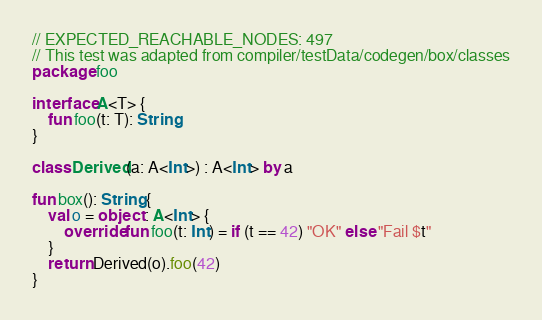<code> <loc_0><loc_0><loc_500><loc_500><_Kotlin_>// EXPECTED_REACHABLE_NODES: 497
// This test was adapted from compiler/testData/codegen/box/classes
package foo

interface A<T> {
    fun foo(t: T): String
}

class Derived(a: A<Int>) : A<Int> by a

fun box(): String {
    val o = object : A<Int> {
        override fun foo(t: Int) = if (t == 42) "OK" else "Fail $t"
    }
    return Derived(o).foo(42)
}
</code> 